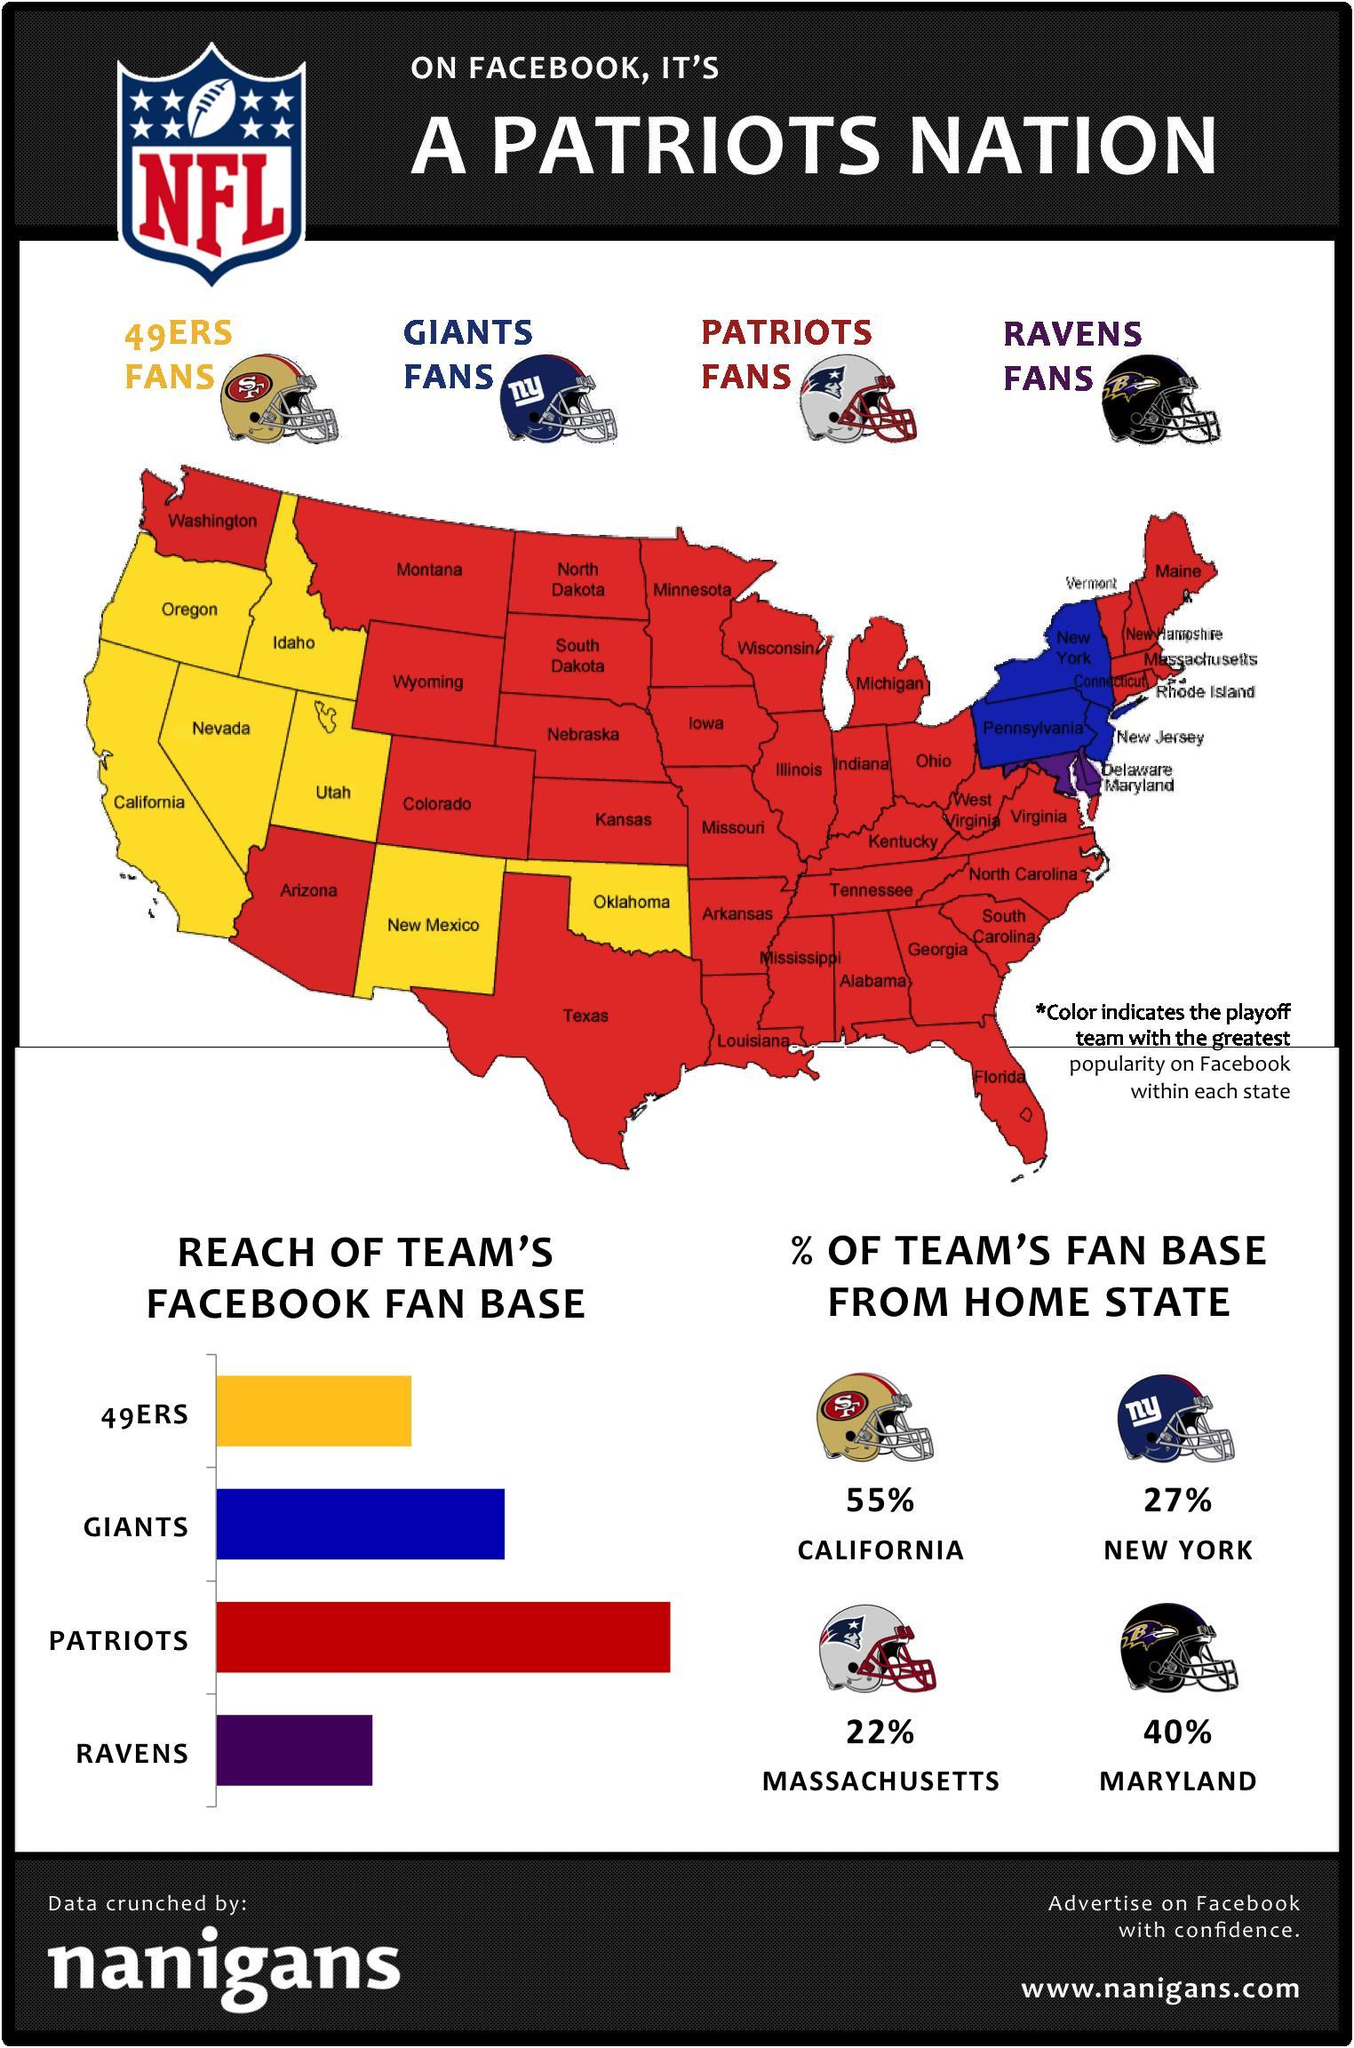Which team has 22% fan base in it's home state?
Answer the question with a short phrase. Patriots Massachusetts is the Home state of which NFL team? Patriots Which is the home state of the Ravens team? Maryland Which is the home state of the Giants team? New York For which team does 55% of Fan base come from home state? 49ers Which team has California as its Home state? 49ers Which team's Facebook fan base has the second highest reach? Giants Which color covers a major area of the map - yellow, blue, red or purple? red What percent of Giants Team's fan base is from home state? 27% In how many states in the map does the 49ers have greatest popularity on Facebook? 7 